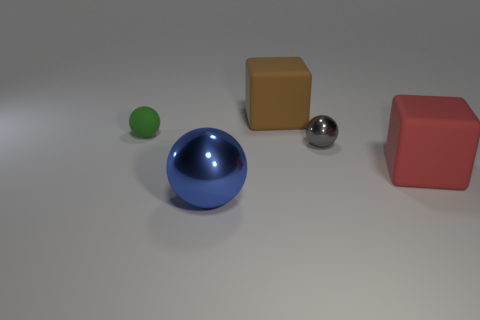Add 1 balls. How many objects exist? 6 Subtract all balls. How many objects are left? 2 Subtract all tiny rubber cylinders. Subtract all big metal objects. How many objects are left? 4 Add 5 brown cubes. How many brown cubes are left? 6 Add 2 big metal cubes. How many big metal cubes exist? 2 Subtract 0 brown cylinders. How many objects are left? 5 